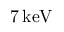Convert formula to latex. <formula><loc_0><loc_0><loc_500><loc_500>7 \, k e V</formula> 